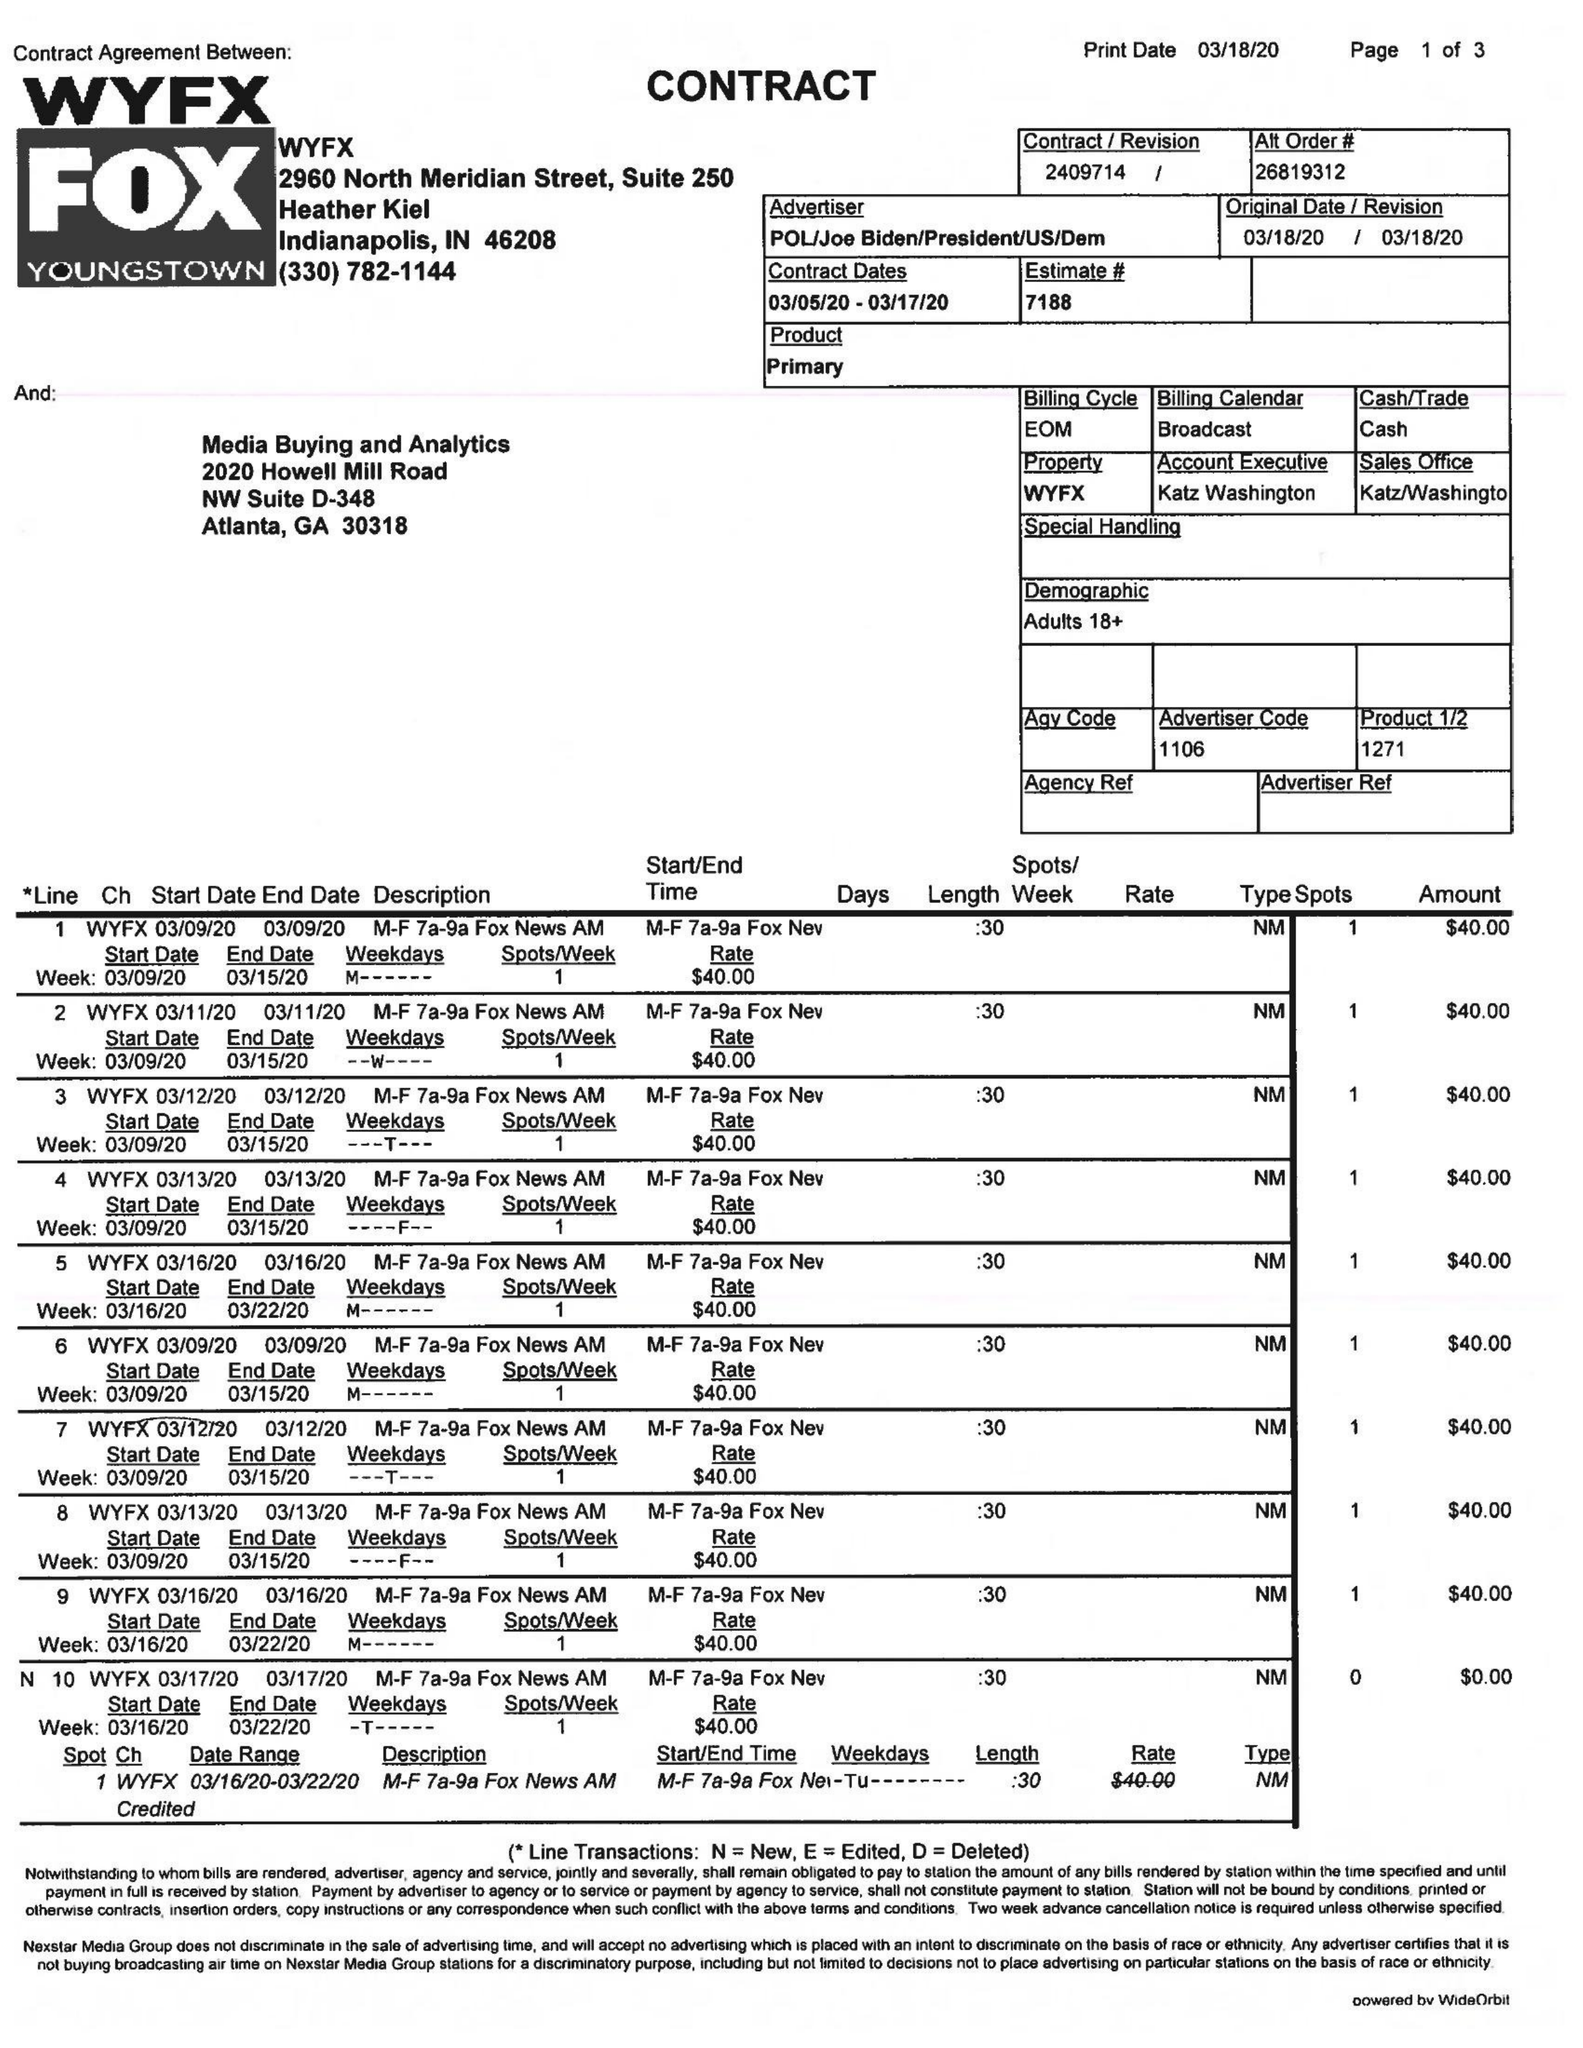What is the value for the contract_num?
Answer the question using a single word or phrase. 2409714 